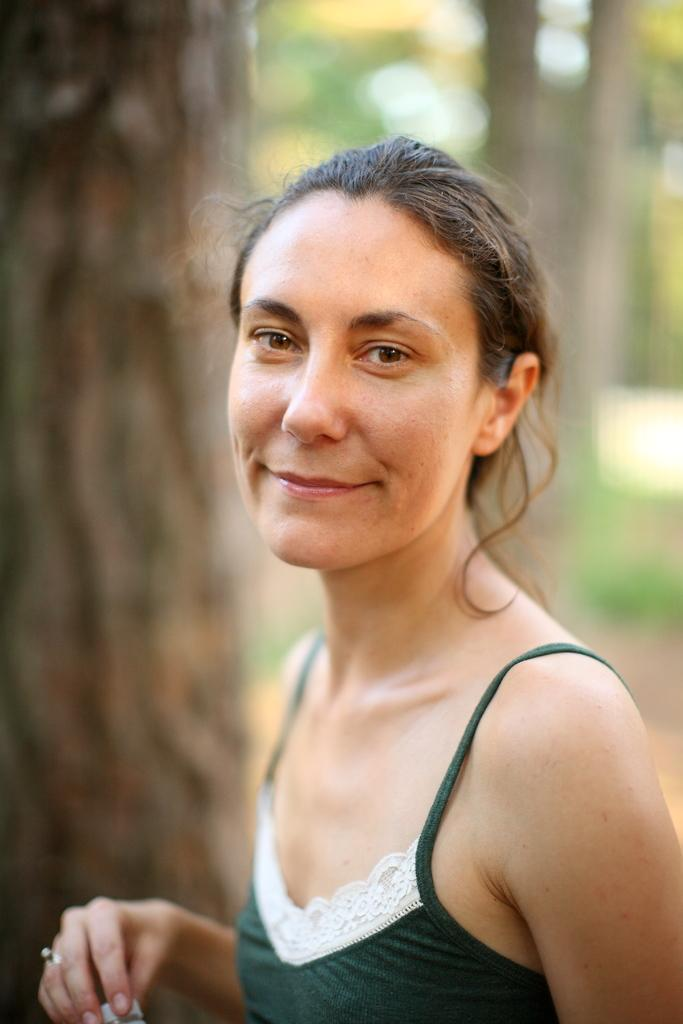Who is present in the image? There is a woman in the image. What is the woman's expression? The woman is smiling. What can be seen in the background of the image? There are trees in the background of the image. What channel does the woman watch on her television in the image? There is no television present in the image, so it is not possible to determine what channel the woman might be watching. 